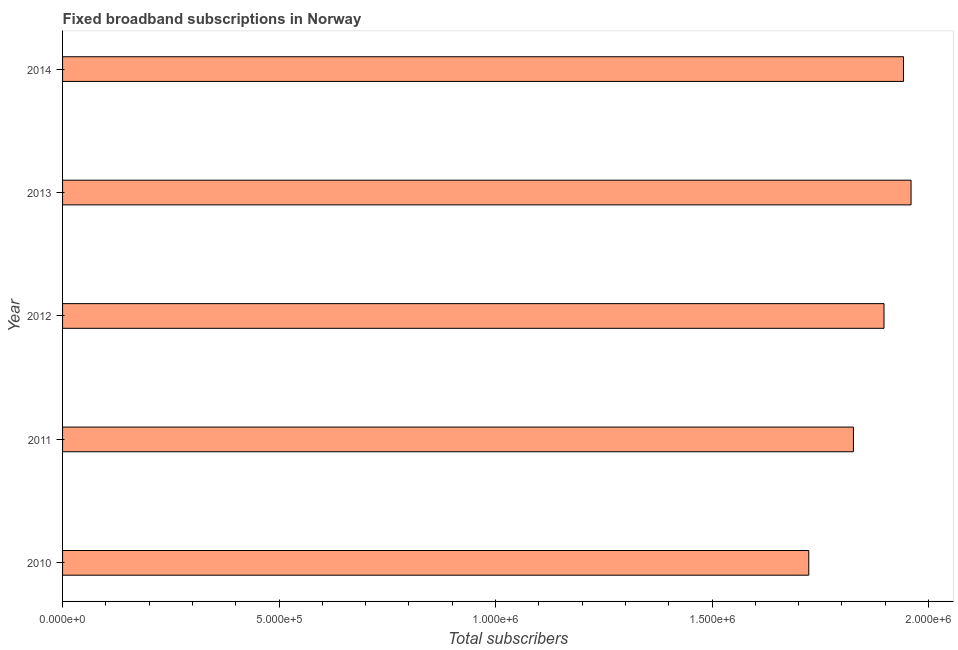Does the graph contain any zero values?
Your answer should be compact. No. Does the graph contain grids?
Make the answer very short. No. What is the title of the graph?
Your response must be concise. Fixed broadband subscriptions in Norway. What is the label or title of the X-axis?
Provide a succinct answer. Total subscribers. What is the total number of fixed broadband subscriptions in 2010?
Offer a very short reply. 1.72e+06. Across all years, what is the maximum total number of fixed broadband subscriptions?
Your answer should be compact. 1.96e+06. Across all years, what is the minimum total number of fixed broadband subscriptions?
Your response must be concise. 1.72e+06. In which year was the total number of fixed broadband subscriptions maximum?
Offer a very short reply. 2013. In which year was the total number of fixed broadband subscriptions minimum?
Make the answer very short. 2010. What is the sum of the total number of fixed broadband subscriptions?
Make the answer very short. 9.35e+06. What is the difference between the total number of fixed broadband subscriptions in 2010 and 2012?
Offer a very short reply. -1.74e+05. What is the average total number of fixed broadband subscriptions per year?
Provide a short and direct response. 1.87e+06. What is the median total number of fixed broadband subscriptions?
Your response must be concise. 1.90e+06. In how many years, is the total number of fixed broadband subscriptions greater than 900000 ?
Ensure brevity in your answer.  5. What is the ratio of the total number of fixed broadband subscriptions in 2012 to that in 2013?
Your response must be concise. 0.97. Is the total number of fixed broadband subscriptions in 2010 less than that in 2011?
Your response must be concise. Yes. Is the difference between the total number of fixed broadband subscriptions in 2012 and 2013 greater than the difference between any two years?
Make the answer very short. No. What is the difference between the highest and the second highest total number of fixed broadband subscriptions?
Make the answer very short. 1.74e+04. What is the difference between the highest and the lowest total number of fixed broadband subscriptions?
Give a very brief answer. 2.36e+05. In how many years, is the total number of fixed broadband subscriptions greater than the average total number of fixed broadband subscriptions taken over all years?
Your response must be concise. 3. Are all the bars in the graph horizontal?
Provide a short and direct response. Yes. How many years are there in the graph?
Keep it short and to the point. 5. What is the Total subscribers in 2010?
Provide a short and direct response. 1.72e+06. What is the Total subscribers of 2011?
Offer a terse response. 1.83e+06. What is the Total subscribers in 2012?
Provide a succinct answer. 1.90e+06. What is the Total subscribers of 2013?
Offer a very short reply. 1.96e+06. What is the Total subscribers in 2014?
Give a very brief answer. 1.94e+06. What is the difference between the Total subscribers in 2010 and 2011?
Offer a very short reply. -1.03e+05. What is the difference between the Total subscribers in 2010 and 2012?
Your answer should be compact. -1.74e+05. What is the difference between the Total subscribers in 2010 and 2013?
Your answer should be compact. -2.36e+05. What is the difference between the Total subscribers in 2010 and 2014?
Give a very brief answer. -2.19e+05. What is the difference between the Total subscribers in 2011 and 2012?
Keep it short and to the point. -7.07e+04. What is the difference between the Total subscribers in 2011 and 2013?
Offer a terse response. -1.33e+05. What is the difference between the Total subscribers in 2011 and 2014?
Make the answer very short. -1.16e+05. What is the difference between the Total subscribers in 2012 and 2013?
Your answer should be compact. -6.25e+04. What is the difference between the Total subscribers in 2012 and 2014?
Ensure brevity in your answer.  -4.50e+04. What is the difference between the Total subscribers in 2013 and 2014?
Provide a short and direct response. 1.74e+04. What is the ratio of the Total subscribers in 2010 to that in 2011?
Make the answer very short. 0.94. What is the ratio of the Total subscribers in 2010 to that in 2012?
Keep it short and to the point. 0.91. What is the ratio of the Total subscribers in 2010 to that in 2013?
Your answer should be compact. 0.88. What is the ratio of the Total subscribers in 2010 to that in 2014?
Keep it short and to the point. 0.89. What is the ratio of the Total subscribers in 2011 to that in 2012?
Provide a succinct answer. 0.96. What is the ratio of the Total subscribers in 2011 to that in 2013?
Provide a short and direct response. 0.93. What is the ratio of the Total subscribers in 2011 to that in 2014?
Your answer should be compact. 0.94. What is the ratio of the Total subscribers in 2012 to that in 2013?
Provide a succinct answer. 0.97. What is the ratio of the Total subscribers in 2012 to that in 2014?
Your response must be concise. 0.98. What is the ratio of the Total subscribers in 2013 to that in 2014?
Provide a succinct answer. 1.01. 